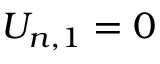Convert formula to latex. <formula><loc_0><loc_0><loc_500><loc_500>{ { U } _ { n , 1 } } = 0</formula> 